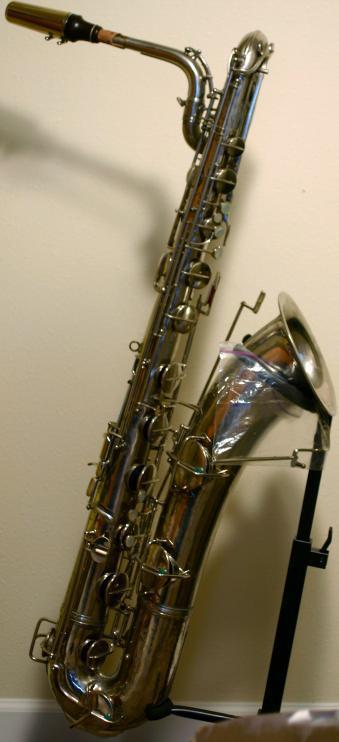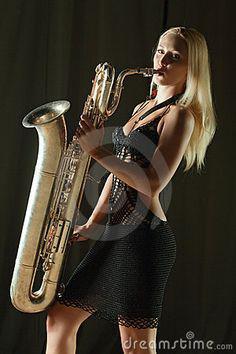The first image is the image on the left, the second image is the image on the right. Analyze the images presented: Is the assertion "The left and right image contains the same number of  fully sized saxophones." valid? Answer yes or no. Yes. The first image is the image on the left, the second image is the image on the right. Considering the images on both sides, is "The left image shows an upright saxophone with its bell facing right, and the right image features one saxophone that is gold-colored." valid? Answer yes or no. Yes. 